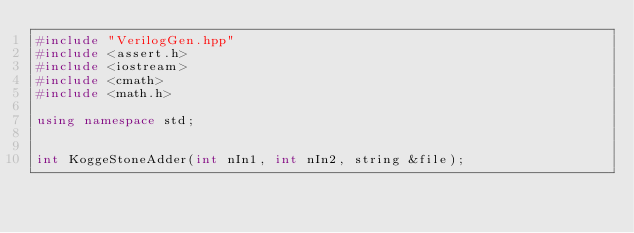<code> <loc_0><loc_0><loc_500><loc_500><_C++_>#include "VerilogGen.hpp"
#include <assert.h>
#include <iostream>
#include <cmath>
#include <math.h>

using namespace std;


int KoggeStoneAdder(int nIn1, int nIn2, string &file);</code> 